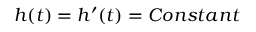<formula> <loc_0><loc_0><loc_500><loc_500>h ( t ) = h ^ { \prime } ( t ) = C o n s t a n t</formula> 